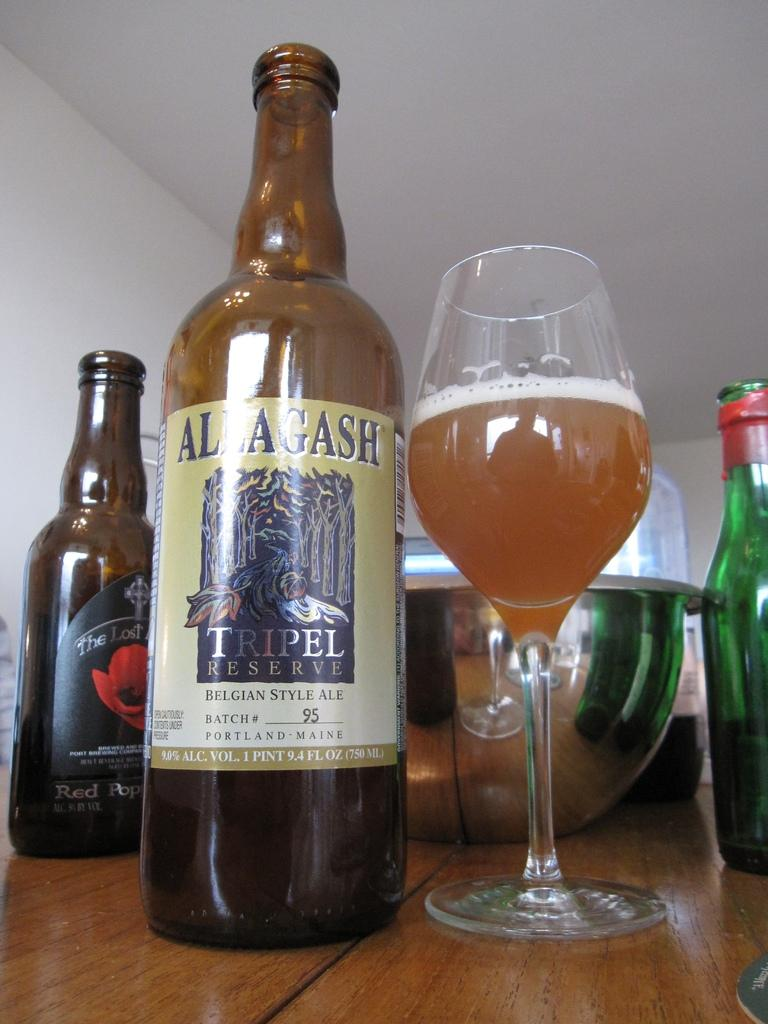<image>
Offer a succinct explanation of the picture presented. A bottle of Allagash Tripel Reserve next to a wine glass 